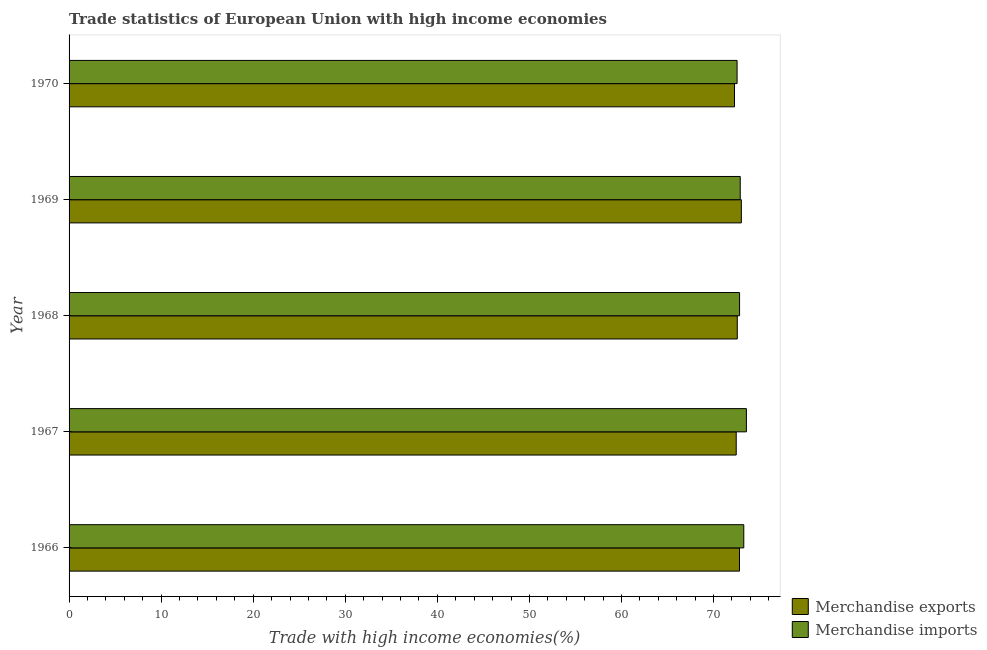How many different coloured bars are there?
Give a very brief answer. 2. How many groups of bars are there?
Provide a short and direct response. 5. Are the number of bars per tick equal to the number of legend labels?
Ensure brevity in your answer.  Yes. Are the number of bars on each tick of the Y-axis equal?
Offer a very short reply. Yes. How many bars are there on the 2nd tick from the top?
Make the answer very short. 2. How many bars are there on the 1st tick from the bottom?
Give a very brief answer. 2. What is the label of the 4th group of bars from the top?
Make the answer very short. 1967. What is the merchandise exports in 1970?
Ensure brevity in your answer.  72.27. Across all years, what is the maximum merchandise imports?
Your answer should be very brief. 73.57. Across all years, what is the minimum merchandise imports?
Provide a succinct answer. 72.56. In which year was the merchandise exports maximum?
Your response must be concise. 1969. What is the total merchandise imports in the graph?
Make the answer very short. 365.13. What is the difference between the merchandise exports in 1967 and that in 1969?
Ensure brevity in your answer.  -0.56. What is the difference between the merchandise exports in 1966 and the merchandise imports in 1969?
Offer a very short reply. -0.08. What is the average merchandise exports per year?
Ensure brevity in your answer.  72.63. In the year 1969, what is the difference between the merchandise exports and merchandise imports?
Give a very brief answer. 0.12. Is the difference between the merchandise imports in 1966 and 1970 greater than the difference between the merchandise exports in 1966 and 1970?
Your response must be concise. Yes. What is the difference between the highest and the second highest merchandise imports?
Give a very brief answer. 0.28. What is the difference between the highest and the lowest merchandise imports?
Provide a succinct answer. 1.01. In how many years, is the merchandise exports greater than the average merchandise exports taken over all years?
Your answer should be very brief. 2. What does the 2nd bar from the bottom in 1967 represents?
Provide a short and direct response. Merchandise imports. Are all the bars in the graph horizontal?
Provide a short and direct response. Yes. What is the difference between two consecutive major ticks on the X-axis?
Your response must be concise. 10. Are the values on the major ticks of X-axis written in scientific E-notation?
Your answer should be compact. No. How are the legend labels stacked?
Your response must be concise. Vertical. What is the title of the graph?
Make the answer very short. Trade statistics of European Union with high income economies. Does "Nitrous oxide" appear as one of the legend labels in the graph?
Offer a very short reply. No. What is the label or title of the X-axis?
Your response must be concise. Trade with high income economies(%). What is the Trade with high income economies(%) in Merchandise exports in 1966?
Your response must be concise. 72.82. What is the Trade with high income economies(%) of Merchandise imports in 1966?
Your response must be concise. 73.28. What is the Trade with high income economies(%) of Merchandise exports in 1967?
Offer a very short reply. 72.46. What is the Trade with high income economies(%) in Merchandise imports in 1967?
Offer a terse response. 73.57. What is the Trade with high income economies(%) of Merchandise exports in 1968?
Ensure brevity in your answer.  72.58. What is the Trade with high income economies(%) in Merchandise imports in 1968?
Give a very brief answer. 72.83. What is the Trade with high income economies(%) of Merchandise exports in 1969?
Your response must be concise. 73.02. What is the Trade with high income economies(%) of Merchandise imports in 1969?
Offer a very short reply. 72.9. What is the Trade with high income economies(%) of Merchandise exports in 1970?
Offer a terse response. 72.27. What is the Trade with high income economies(%) of Merchandise imports in 1970?
Keep it short and to the point. 72.56. Across all years, what is the maximum Trade with high income economies(%) of Merchandise exports?
Offer a very short reply. 73.02. Across all years, what is the maximum Trade with high income economies(%) in Merchandise imports?
Offer a very short reply. 73.57. Across all years, what is the minimum Trade with high income economies(%) of Merchandise exports?
Ensure brevity in your answer.  72.27. Across all years, what is the minimum Trade with high income economies(%) in Merchandise imports?
Your answer should be very brief. 72.56. What is the total Trade with high income economies(%) of Merchandise exports in the graph?
Provide a short and direct response. 363.15. What is the total Trade with high income economies(%) of Merchandise imports in the graph?
Your answer should be very brief. 365.13. What is the difference between the Trade with high income economies(%) of Merchandise exports in 1966 and that in 1967?
Make the answer very short. 0.36. What is the difference between the Trade with high income economies(%) of Merchandise imports in 1966 and that in 1967?
Your answer should be very brief. -0.28. What is the difference between the Trade with high income economies(%) in Merchandise exports in 1966 and that in 1968?
Offer a very short reply. 0.24. What is the difference between the Trade with high income economies(%) in Merchandise imports in 1966 and that in 1968?
Provide a succinct answer. 0.46. What is the difference between the Trade with high income economies(%) of Merchandise exports in 1966 and that in 1969?
Provide a succinct answer. -0.2. What is the difference between the Trade with high income economies(%) of Merchandise imports in 1966 and that in 1969?
Provide a succinct answer. 0.39. What is the difference between the Trade with high income economies(%) of Merchandise exports in 1966 and that in 1970?
Offer a terse response. 0.54. What is the difference between the Trade with high income economies(%) in Merchandise imports in 1966 and that in 1970?
Offer a terse response. 0.73. What is the difference between the Trade with high income economies(%) of Merchandise exports in 1967 and that in 1968?
Provide a succinct answer. -0.12. What is the difference between the Trade with high income economies(%) of Merchandise imports in 1967 and that in 1968?
Your response must be concise. 0.74. What is the difference between the Trade with high income economies(%) in Merchandise exports in 1967 and that in 1969?
Provide a short and direct response. -0.56. What is the difference between the Trade with high income economies(%) in Merchandise imports in 1967 and that in 1969?
Provide a succinct answer. 0.67. What is the difference between the Trade with high income economies(%) of Merchandise exports in 1967 and that in 1970?
Provide a succinct answer. 0.19. What is the difference between the Trade with high income economies(%) in Merchandise imports in 1967 and that in 1970?
Make the answer very short. 1.01. What is the difference between the Trade with high income economies(%) in Merchandise exports in 1968 and that in 1969?
Offer a terse response. -0.44. What is the difference between the Trade with high income economies(%) in Merchandise imports in 1968 and that in 1969?
Offer a terse response. -0.07. What is the difference between the Trade with high income economies(%) of Merchandise exports in 1968 and that in 1970?
Ensure brevity in your answer.  0.3. What is the difference between the Trade with high income economies(%) in Merchandise imports in 1968 and that in 1970?
Your response must be concise. 0.27. What is the difference between the Trade with high income economies(%) of Merchandise exports in 1969 and that in 1970?
Ensure brevity in your answer.  0.74. What is the difference between the Trade with high income economies(%) in Merchandise imports in 1969 and that in 1970?
Keep it short and to the point. 0.34. What is the difference between the Trade with high income economies(%) of Merchandise exports in 1966 and the Trade with high income economies(%) of Merchandise imports in 1967?
Keep it short and to the point. -0.75. What is the difference between the Trade with high income economies(%) in Merchandise exports in 1966 and the Trade with high income economies(%) in Merchandise imports in 1968?
Ensure brevity in your answer.  -0.01. What is the difference between the Trade with high income economies(%) of Merchandise exports in 1966 and the Trade with high income economies(%) of Merchandise imports in 1969?
Make the answer very short. -0.08. What is the difference between the Trade with high income economies(%) of Merchandise exports in 1966 and the Trade with high income economies(%) of Merchandise imports in 1970?
Offer a terse response. 0.26. What is the difference between the Trade with high income economies(%) of Merchandise exports in 1967 and the Trade with high income economies(%) of Merchandise imports in 1968?
Make the answer very short. -0.36. What is the difference between the Trade with high income economies(%) of Merchandise exports in 1967 and the Trade with high income economies(%) of Merchandise imports in 1969?
Ensure brevity in your answer.  -0.44. What is the difference between the Trade with high income economies(%) in Merchandise exports in 1967 and the Trade with high income economies(%) in Merchandise imports in 1970?
Ensure brevity in your answer.  -0.09. What is the difference between the Trade with high income economies(%) of Merchandise exports in 1968 and the Trade with high income economies(%) of Merchandise imports in 1969?
Offer a very short reply. -0.32. What is the difference between the Trade with high income economies(%) of Merchandise exports in 1968 and the Trade with high income economies(%) of Merchandise imports in 1970?
Keep it short and to the point. 0.02. What is the difference between the Trade with high income economies(%) of Merchandise exports in 1969 and the Trade with high income economies(%) of Merchandise imports in 1970?
Ensure brevity in your answer.  0.46. What is the average Trade with high income economies(%) in Merchandise exports per year?
Make the answer very short. 72.63. What is the average Trade with high income economies(%) of Merchandise imports per year?
Your answer should be compact. 73.03. In the year 1966, what is the difference between the Trade with high income economies(%) in Merchandise exports and Trade with high income economies(%) in Merchandise imports?
Your answer should be compact. -0.47. In the year 1967, what is the difference between the Trade with high income economies(%) in Merchandise exports and Trade with high income economies(%) in Merchandise imports?
Provide a short and direct response. -1.11. In the year 1968, what is the difference between the Trade with high income economies(%) in Merchandise exports and Trade with high income economies(%) in Merchandise imports?
Your answer should be compact. -0.25. In the year 1969, what is the difference between the Trade with high income economies(%) in Merchandise exports and Trade with high income economies(%) in Merchandise imports?
Give a very brief answer. 0.12. In the year 1970, what is the difference between the Trade with high income economies(%) in Merchandise exports and Trade with high income economies(%) in Merchandise imports?
Your answer should be compact. -0.28. What is the ratio of the Trade with high income economies(%) of Merchandise exports in 1966 to that in 1967?
Offer a very short reply. 1. What is the ratio of the Trade with high income economies(%) of Merchandise imports in 1966 to that in 1967?
Keep it short and to the point. 1. What is the ratio of the Trade with high income economies(%) of Merchandise exports in 1966 to that in 1968?
Offer a very short reply. 1. What is the ratio of the Trade with high income economies(%) of Merchandise imports in 1966 to that in 1968?
Give a very brief answer. 1.01. What is the ratio of the Trade with high income economies(%) of Merchandise exports in 1966 to that in 1970?
Provide a succinct answer. 1.01. What is the ratio of the Trade with high income economies(%) in Merchandise imports in 1966 to that in 1970?
Ensure brevity in your answer.  1.01. What is the ratio of the Trade with high income economies(%) of Merchandise exports in 1967 to that in 1968?
Your response must be concise. 1. What is the ratio of the Trade with high income economies(%) of Merchandise imports in 1967 to that in 1968?
Your answer should be very brief. 1.01. What is the ratio of the Trade with high income economies(%) of Merchandise imports in 1967 to that in 1969?
Ensure brevity in your answer.  1.01. What is the ratio of the Trade with high income economies(%) of Merchandise exports in 1967 to that in 1970?
Your answer should be very brief. 1. What is the ratio of the Trade with high income economies(%) in Merchandise imports in 1967 to that in 1970?
Your answer should be very brief. 1.01. What is the ratio of the Trade with high income economies(%) of Merchandise imports in 1968 to that in 1970?
Ensure brevity in your answer.  1. What is the ratio of the Trade with high income economies(%) of Merchandise exports in 1969 to that in 1970?
Make the answer very short. 1.01. What is the ratio of the Trade with high income economies(%) in Merchandise imports in 1969 to that in 1970?
Offer a very short reply. 1. What is the difference between the highest and the second highest Trade with high income economies(%) of Merchandise exports?
Keep it short and to the point. 0.2. What is the difference between the highest and the second highest Trade with high income economies(%) in Merchandise imports?
Keep it short and to the point. 0.28. What is the difference between the highest and the lowest Trade with high income economies(%) in Merchandise exports?
Ensure brevity in your answer.  0.74. What is the difference between the highest and the lowest Trade with high income economies(%) of Merchandise imports?
Your response must be concise. 1.01. 